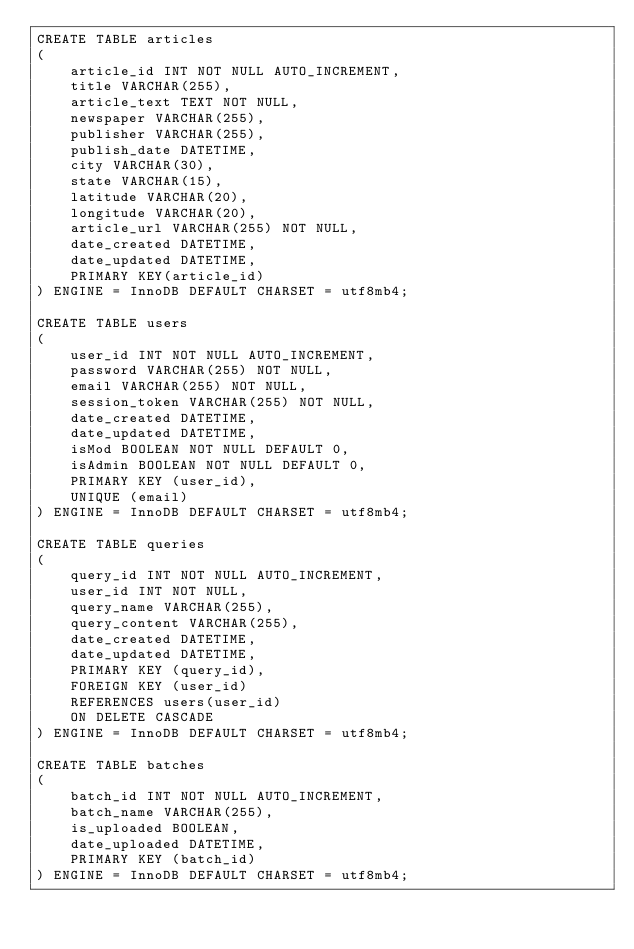<code> <loc_0><loc_0><loc_500><loc_500><_SQL_>CREATE TABLE articles
(
    article_id INT NOT NULL AUTO_INCREMENT,
    title VARCHAR(255),
    article_text TEXT NOT NULL,
    newspaper VARCHAR(255),
    publisher VARCHAR(255),
    publish_date DATETIME,
    city VARCHAR(30),
    state VARCHAR(15),
    latitude VARCHAR(20),
    longitude VARCHAR(20),
    article_url VARCHAR(255) NOT NULL,
    date_created DATETIME,
    date_updated DATETIME,
    PRIMARY KEY(article_id)
) ENGINE = InnoDB DEFAULT CHARSET = utf8mb4;

CREATE TABLE users
(
    user_id INT NOT NULL AUTO_INCREMENT,
    password VARCHAR(255) NOT NULL, 
    email VARCHAR(255) NOT NULL,
    session_token VARCHAR(255) NOT NULL,
    date_created DATETIME,
    date_updated DATETIME,
    isMod BOOLEAN NOT NULL DEFAULT 0,
    isAdmin BOOLEAN NOT NULL DEFAULT 0,
    PRIMARY KEY (user_id),
    UNIQUE (email)
) ENGINE = InnoDB DEFAULT CHARSET = utf8mb4;

CREATE TABLE queries
(
    query_id INT NOT NULL AUTO_INCREMENT,
    user_id INT NOT NULL,
    query_name VARCHAR(255),
    query_content VARCHAR(255),
    date_created DATETIME,
    date_updated DATETIME,
    PRIMARY KEY (query_id),
    FOREIGN KEY (user_id)
    REFERENCES users(user_id)
		ON DELETE CASCADE
) ENGINE = InnoDB DEFAULT CHARSET = utf8mb4;

CREATE TABLE batches
(
    batch_id INT NOT NULL AUTO_INCREMENT,
    batch_name VARCHAR(255),
    is_uploaded BOOLEAN,
    date_uploaded DATETIME,
    PRIMARY KEY (batch_id)
) ENGINE = InnoDB DEFAULT CHARSET = utf8mb4;


</code> 